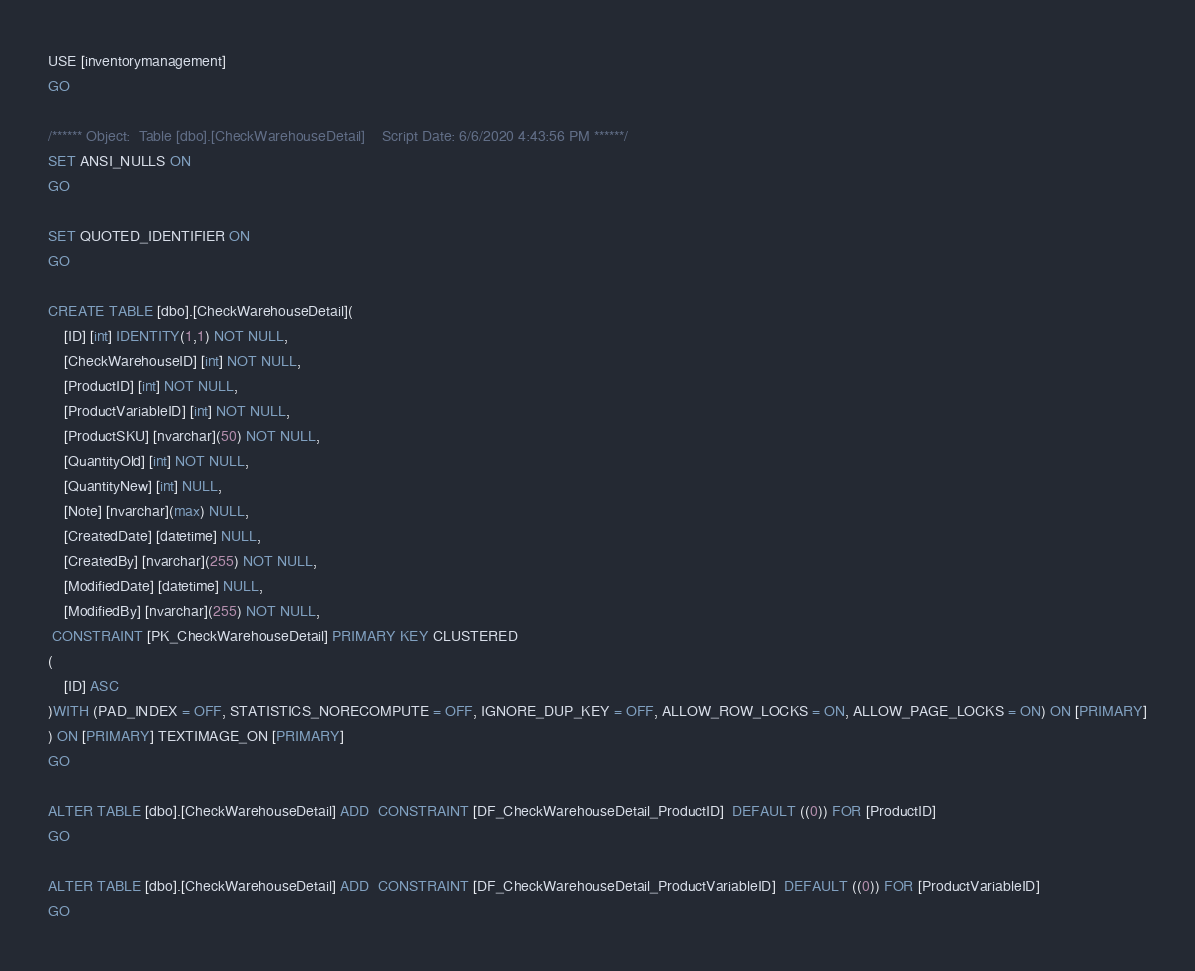<code> <loc_0><loc_0><loc_500><loc_500><_SQL_>USE [inventorymanagement]
GO

/****** Object:  Table [dbo].[CheckWarehouseDetail]    Script Date: 6/6/2020 4:43:56 PM ******/
SET ANSI_NULLS ON
GO

SET QUOTED_IDENTIFIER ON
GO

CREATE TABLE [dbo].[CheckWarehouseDetail](
	[ID] [int] IDENTITY(1,1) NOT NULL,
	[CheckWarehouseID] [int] NOT NULL,
	[ProductID] [int] NOT NULL,
	[ProductVariableID] [int] NOT NULL,
	[ProductSKU] [nvarchar](50) NOT NULL,
	[QuantityOld] [int] NOT NULL,
	[QuantityNew] [int] NULL,
	[Note] [nvarchar](max) NULL,
	[CreatedDate] [datetime] NULL,
	[CreatedBy] [nvarchar](255) NOT NULL,
	[ModifiedDate] [datetime] NULL,
	[ModifiedBy] [nvarchar](255) NOT NULL,
 CONSTRAINT [PK_CheckWarehouseDetail] PRIMARY KEY CLUSTERED 
(
	[ID] ASC
)WITH (PAD_INDEX = OFF, STATISTICS_NORECOMPUTE = OFF, IGNORE_DUP_KEY = OFF, ALLOW_ROW_LOCKS = ON, ALLOW_PAGE_LOCKS = ON) ON [PRIMARY]
) ON [PRIMARY] TEXTIMAGE_ON [PRIMARY]
GO

ALTER TABLE [dbo].[CheckWarehouseDetail] ADD  CONSTRAINT [DF_CheckWarehouseDetail_ProductID]  DEFAULT ((0)) FOR [ProductID]
GO

ALTER TABLE [dbo].[CheckWarehouseDetail] ADD  CONSTRAINT [DF_CheckWarehouseDetail_ProductVariableID]  DEFAULT ((0)) FOR [ProductVariableID]
GO


</code> 